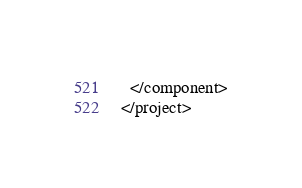Convert code to text. <code><loc_0><loc_0><loc_500><loc_500><_XML_>  </component>
</project></code> 